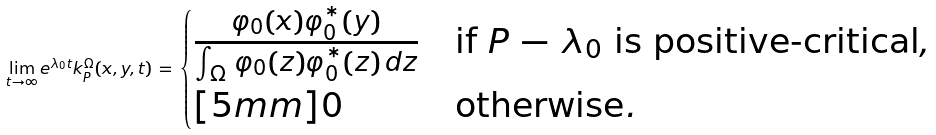Convert formula to latex. <formula><loc_0><loc_0><loc_500><loc_500>\lim _ { t \to \infty } e ^ { \lambda _ { 0 } t } k _ { P } ^ { \Omega } ( x , y , t ) \, = \, \begin{cases} \frac { \varphi _ { 0 } ( x ) \varphi _ { 0 } ^ { * } ( y ) } { \int _ { \Omega } \, \varphi _ { 0 } ( z ) \varphi _ { 0 } ^ { * } ( z ) \, d z } & \text {if } P \, - \, \lambda _ { 0 } \text { is positive-critical} , \\ [ 5 m m ] 0 & \text {otherwise} . \end{cases}</formula> 